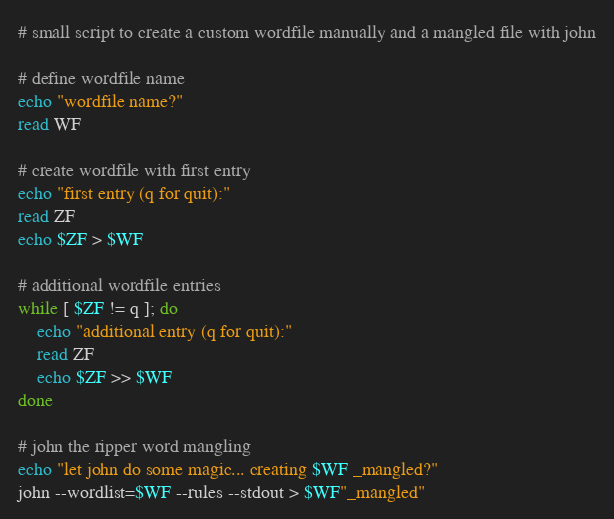Convert code to text. <code><loc_0><loc_0><loc_500><loc_500><_Bash_># small script to create a custom wordfile manually and a mangled file with john

# define wordfile name
echo "wordfile name?"
read WF

# create wordfile with first entry
echo "first entry (q for quit):"
read ZF
echo $ZF > $WF

# additional wordfile entries
while [ $ZF != q ]; do
	echo "additional entry (q for quit):"
	read ZF
	echo $ZF >> $WF
done

# john the ripper word mangling
echo "let john do some magic... creating $WF _mangled?"
john --wordlist=$WF --rules --stdout > $WF"_mangled"
</code> 